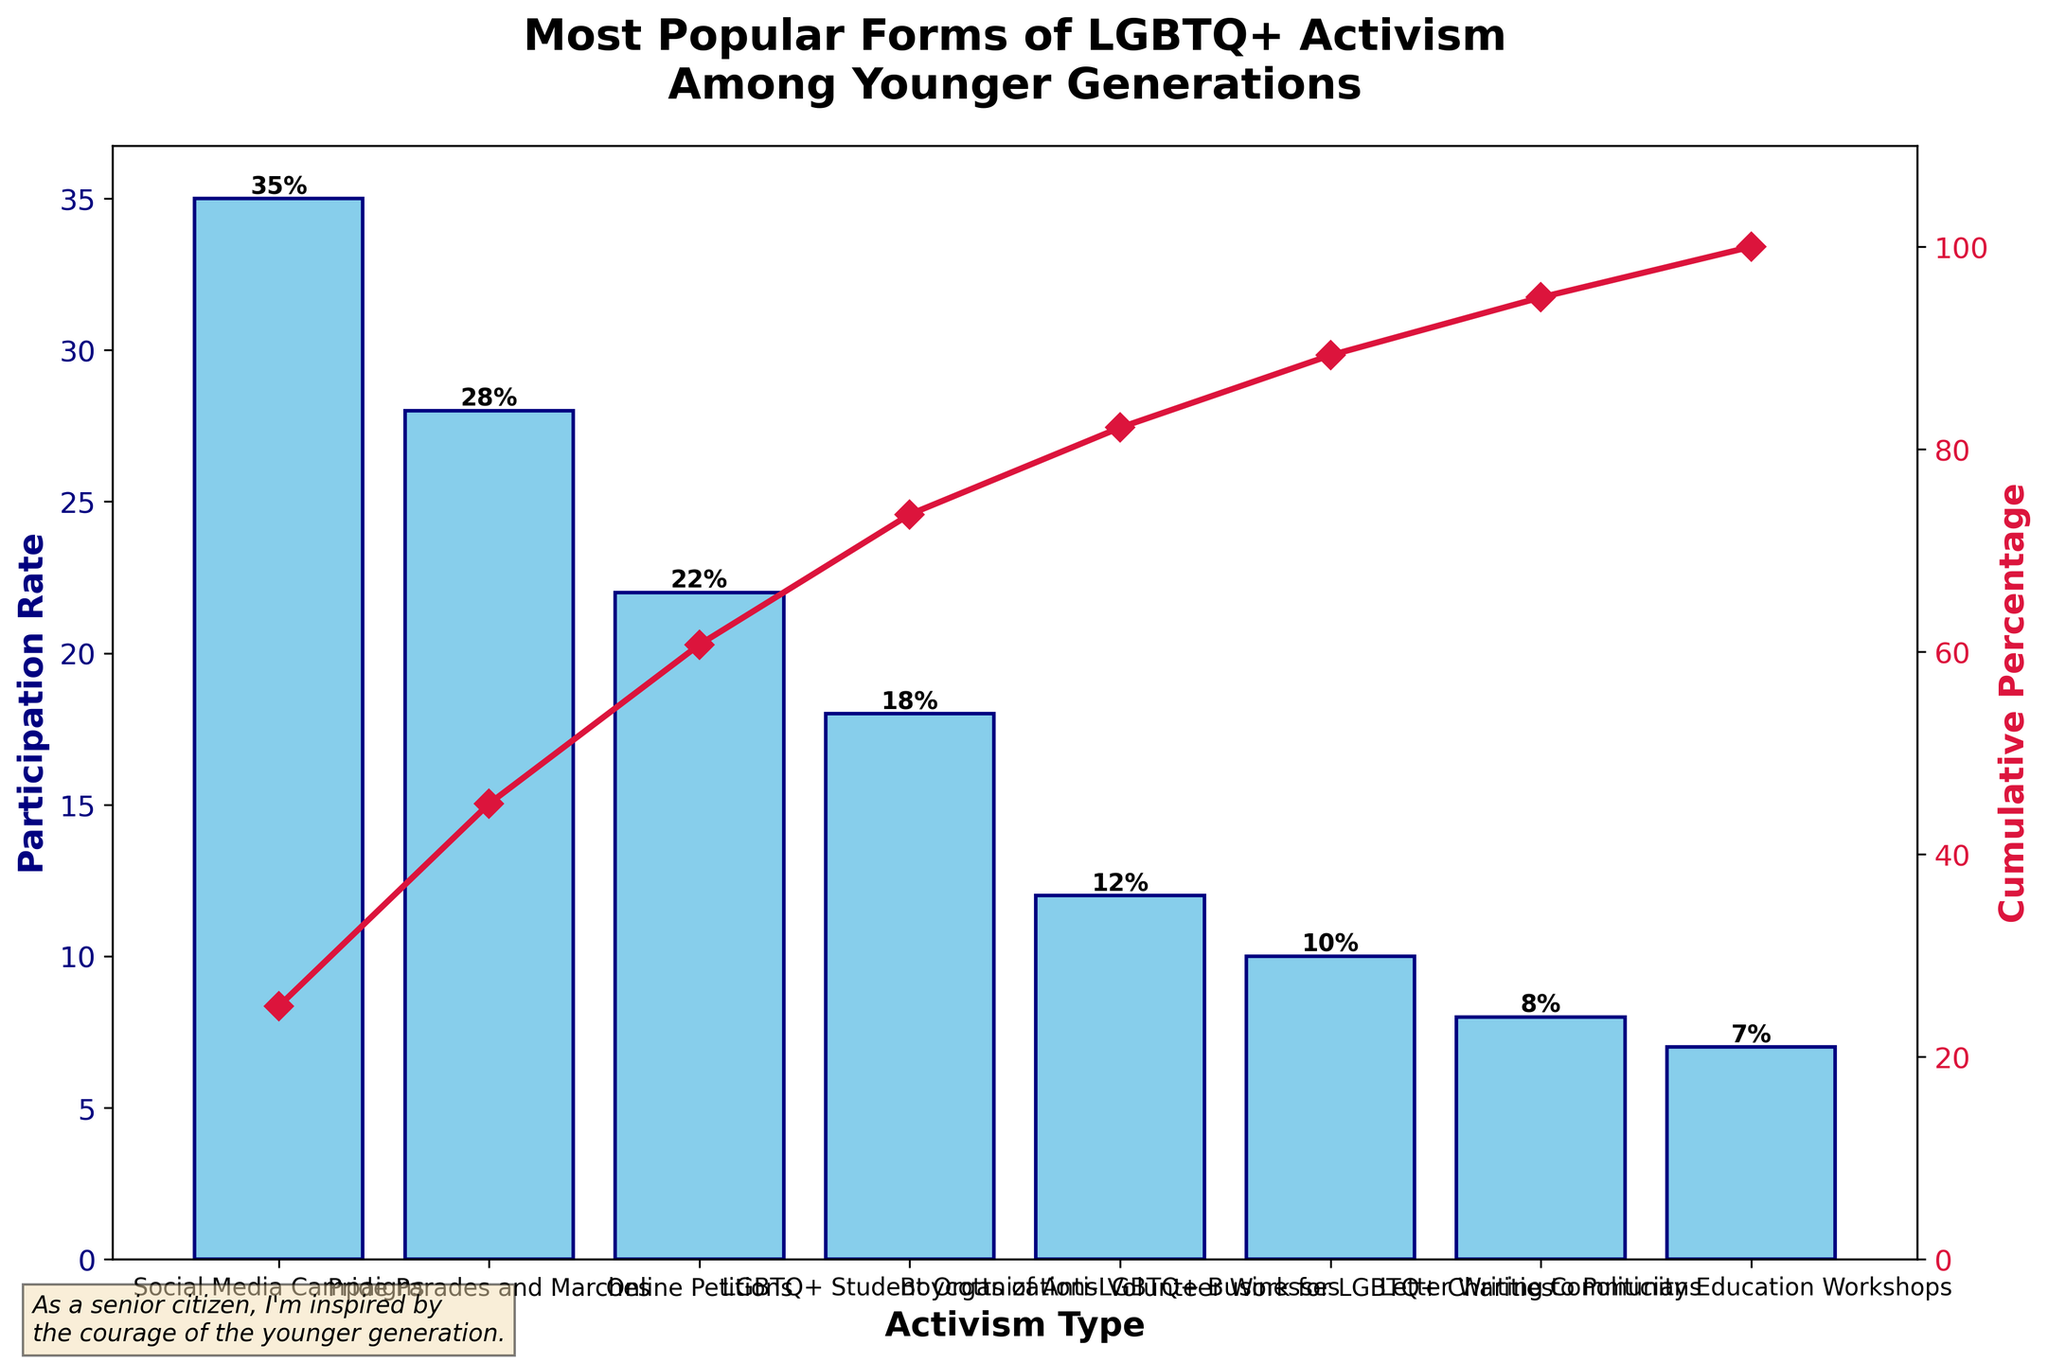Which form of LGBTQ+ activism has the highest participation rate among the younger generation? The figure shows various forms of LGBTQ+ activism along the x-axis with their respective participation rates on the y-axis. The highest bar represents Social Media Campaigns at 35%.
Answer: Social Media Campaigns What is the participation rate for Pride Parades and Marches? The figure indicates the participation rates of different forms of activism. For Pride Parades and Marches, the bar reaches 28%.
Answer: 28% Which two forms of activism have participation rates closest to each other? By visually inspecting the heights of the bars, LGBTQ+ Student Organizations (18%) and Boycotts of Anti-LGBTQ+ Businesses (12%) have rates relatively close to each other compared to other pairs.
Answer: LGBTQ+ Student Organizations and Boycotts of Anti-LGBTQ+ Businesses What is the cumulative percentage participation rate after including Online Petitions? Cumulative percentage lines are plotted in the figure. For Online Petitions, the cumulative rate is 85%, adding Social Media Campaigns (35%), Pride Parades and Marches (28%), and Online Petitions (22%).
Answer: 85% How does the participation rate for Community Education Workshops compare to that for Volunteer Work for LGBTQ+ Charities? Community Education Workshops have a lower bar at 7%, compared to Volunteer Work for LGBTQ+ Charities which has a bar at 10%.
Answer: Lower What is the sixth most popular form of activism by participation rate? The x-axis shows various forms of activism sorted by participation rate. The sixth bar corresponds to Volunteer Work for LGBTQ+ Charities at 10%.
Answer: Volunteer Work for LGBTQ+ Charities What is the difference in participation rates between the highest and lowest forms of activism? The highest participation rate is Social Media Campaigns at 35%, and the lowest is Community Education Workshops at 7%. The difference is 35% - 7% = 28%.
Answer: 28% What is the total percentage participation rate represented by the top three forms of activism? The top three forms of activism are Social Media Campaigns (35%), Pride Parades and Marches (28%), and Online Petitions (22%). The total is 35% + 28% + 22% = 85%.
Answer: 85% What percentage of participants are involved in activities other than the top four most popular forms? The top four forms of activism are Social Media Campaigns, Pride Parades and Marches, Online Petitions, and LGBTQ+ Student Organizations. Summing their rates gives 35% + 28% + 22% + 18% = 103%. The total participation percentage is 150%. So, 150% - 103% = 47%.
Answer: 47% Describe the appearance of the line indicating the cumulative percentage. The line starts at 35% for Social Media Campaigns and gradually rises as each additional form of activism is added, hitting 100% at the final data point.
Answer: Gradually rising line 